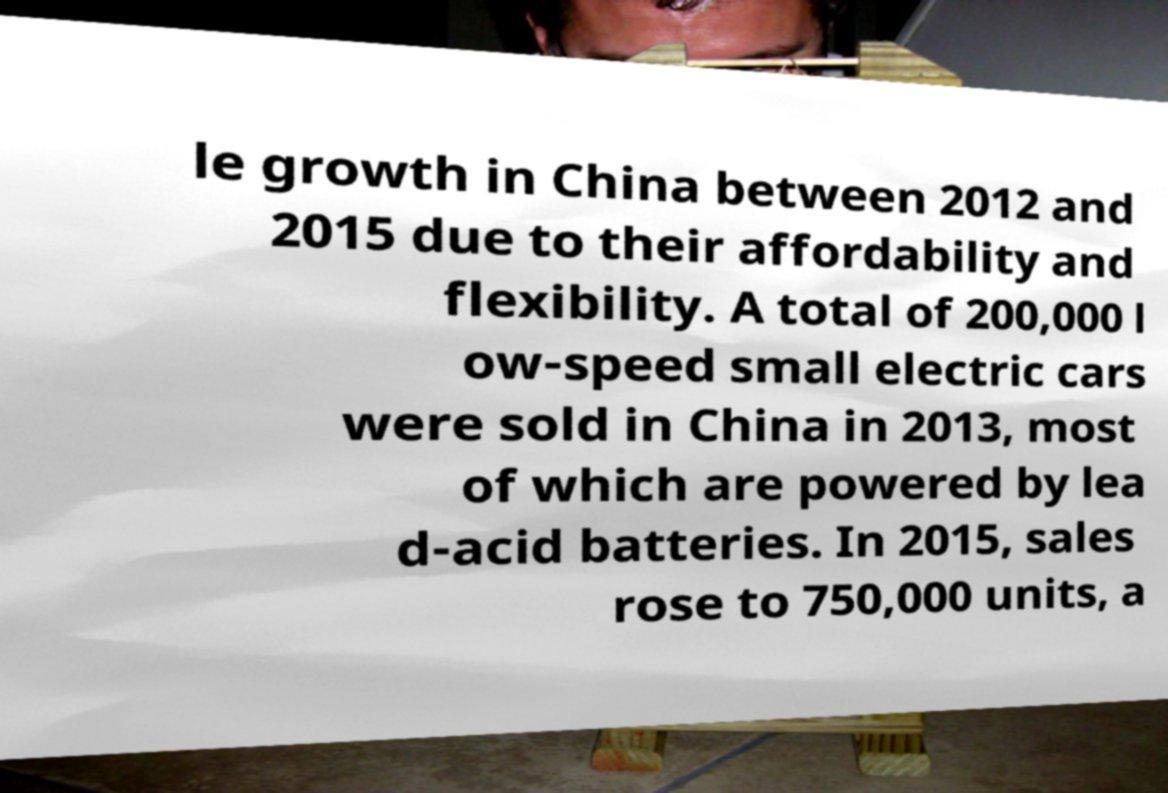For documentation purposes, I need the text within this image transcribed. Could you provide that? le growth in China between 2012 and 2015 due to their affordability and flexibility. A total of 200,000 l ow-speed small electric cars were sold in China in 2013, most of which are powered by lea d-acid batteries. In 2015, sales rose to 750,000 units, a 